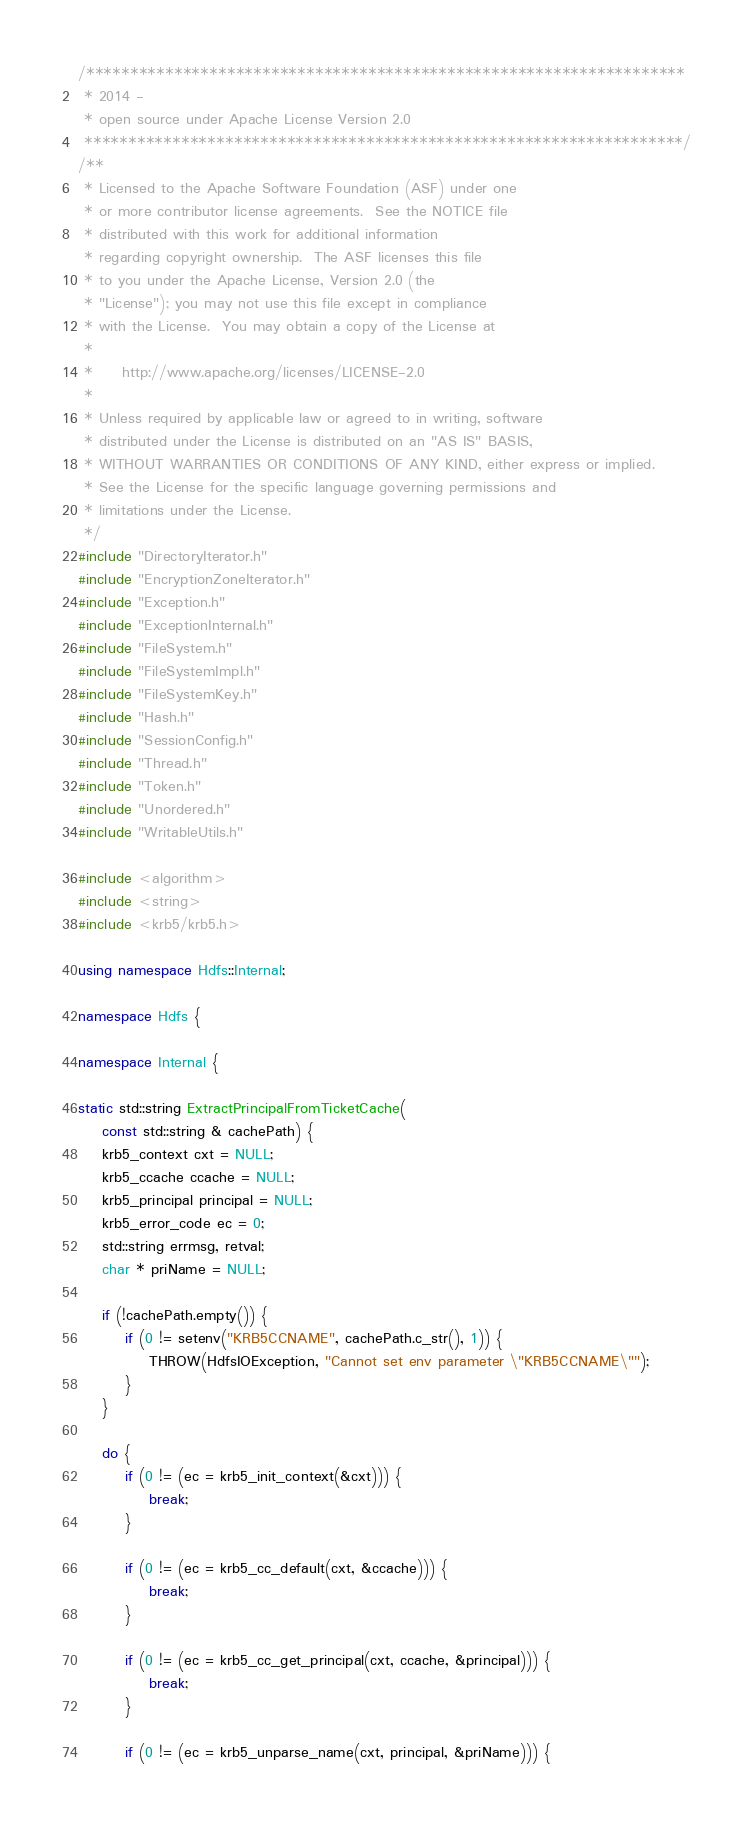Convert code to text. <code><loc_0><loc_0><loc_500><loc_500><_C++_>/********************************************************************
 * 2014 -
 * open source under Apache License Version 2.0
 ********************************************************************/
/**
 * Licensed to the Apache Software Foundation (ASF) under one
 * or more contributor license agreements.  See the NOTICE file
 * distributed with this work for additional information
 * regarding copyright ownership.  The ASF licenses this file
 * to you under the Apache License, Version 2.0 (the
 * "License"); you may not use this file except in compliance
 * with the License.  You may obtain a copy of the License at
 *
 *     http://www.apache.org/licenses/LICENSE-2.0
 *
 * Unless required by applicable law or agreed to in writing, software
 * distributed under the License is distributed on an "AS IS" BASIS,
 * WITHOUT WARRANTIES OR CONDITIONS OF ANY KIND, either express or implied.
 * See the License for the specific language governing permissions and
 * limitations under the License.
 */
#include "DirectoryIterator.h"
#include "EncryptionZoneIterator.h"
#include "Exception.h"
#include "ExceptionInternal.h"
#include "FileSystem.h"
#include "FileSystemImpl.h"
#include "FileSystemKey.h"
#include "Hash.h"
#include "SessionConfig.h"
#include "Thread.h"
#include "Token.h"
#include "Unordered.h"
#include "WritableUtils.h"

#include <algorithm>
#include <string>
#include <krb5/krb5.h>

using namespace Hdfs::Internal;

namespace Hdfs {

namespace Internal {

static std::string ExtractPrincipalFromTicketCache(
    const std::string & cachePath) {
    krb5_context cxt = NULL;
    krb5_ccache ccache = NULL;
    krb5_principal principal = NULL;
    krb5_error_code ec = 0;
    std::string errmsg, retval;
    char * priName = NULL;

    if (!cachePath.empty()) {
        if (0 != setenv("KRB5CCNAME", cachePath.c_str(), 1)) {
            THROW(HdfsIOException, "Cannot set env parameter \"KRB5CCNAME\"");
        }
    }

    do {
        if (0 != (ec = krb5_init_context(&cxt))) {
            break;
        }

        if (0 != (ec = krb5_cc_default(cxt, &ccache))) {
            break;
        }

        if (0 != (ec = krb5_cc_get_principal(cxt, ccache, &principal))) {
            break;
        }

        if (0 != (ec = krb5_unparse_name(cxt, principal, &priName))) {</code> 